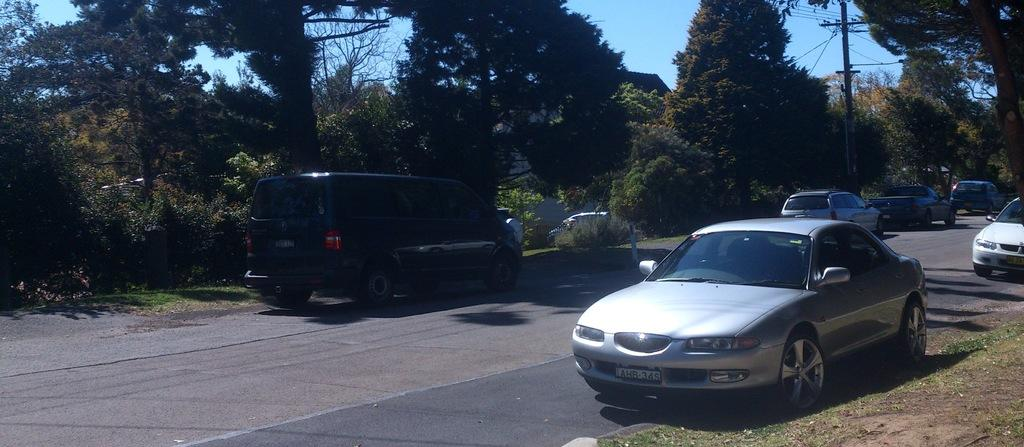What is the main feature of the image? There is a road in the image. What is happening on the road? There are vehicles on the road. What can be seen in the background of the image? There are trees in the background of the image. What else is present in the image besides the road and vehicles? There are electric poles in the image. What type of underwear is hanging on the electric poles in the image? There is no underwear present in the image; only the road, vehicles, trees, and electric poles are visible. 